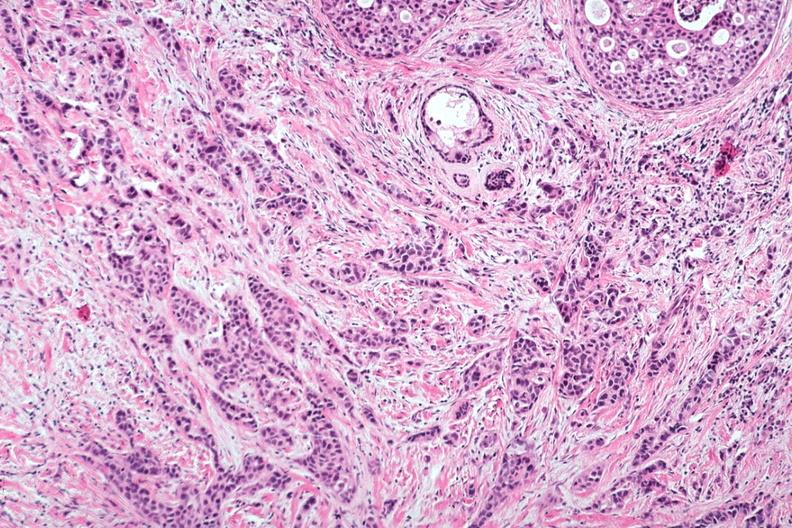s very good example present?
Answer the question using a single word or phrase. No 